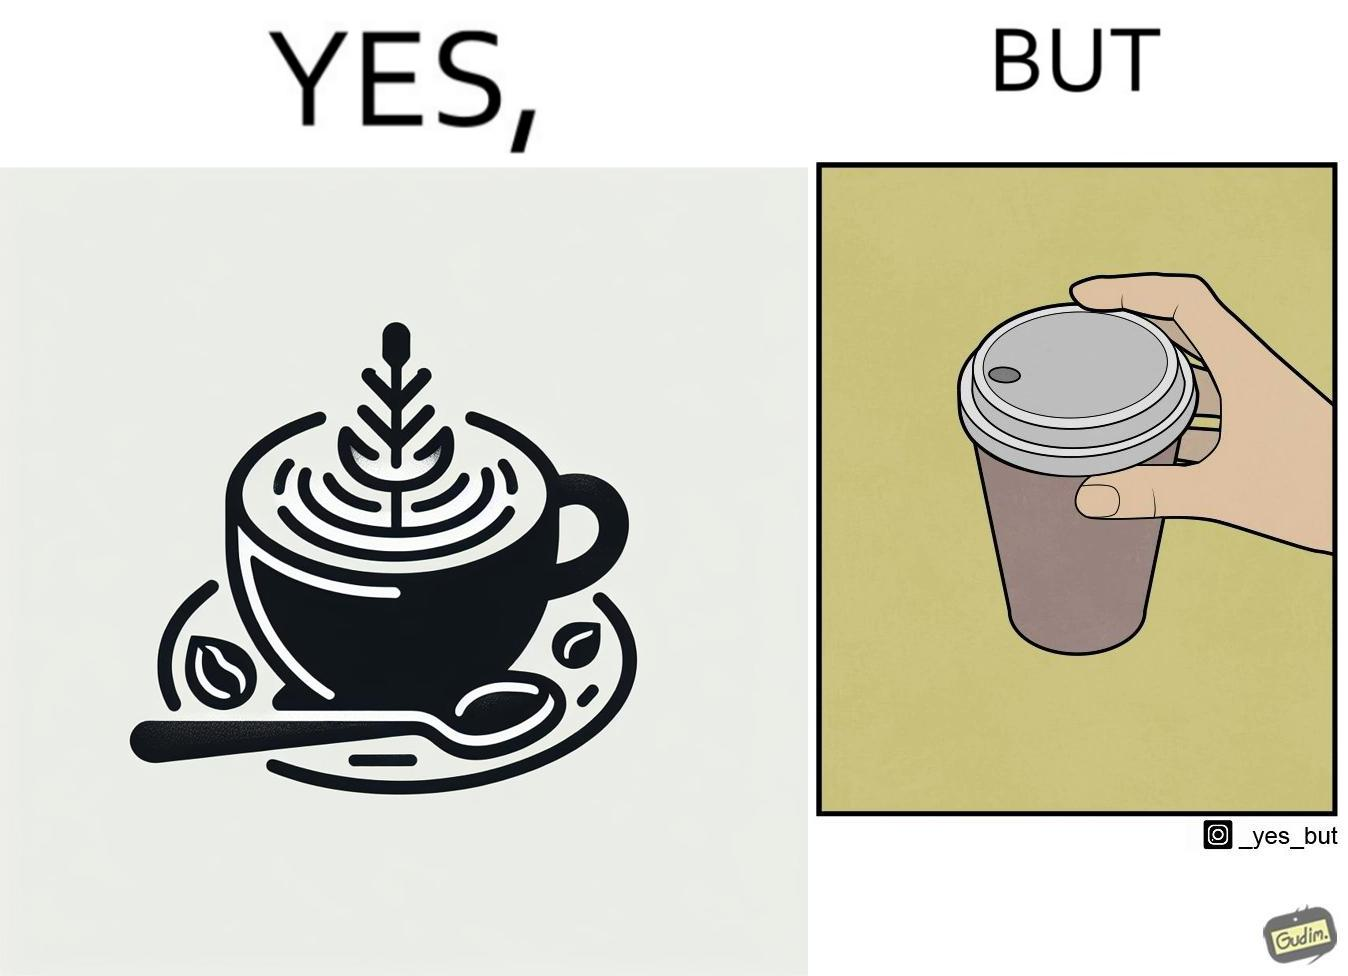Explain the humor or irony in this image. The images are funny since it shows how someone has put effort into a cup of coffee to do latte art on it only for it to be invisible after a lid is put on the coffee cup before serving to a customer 